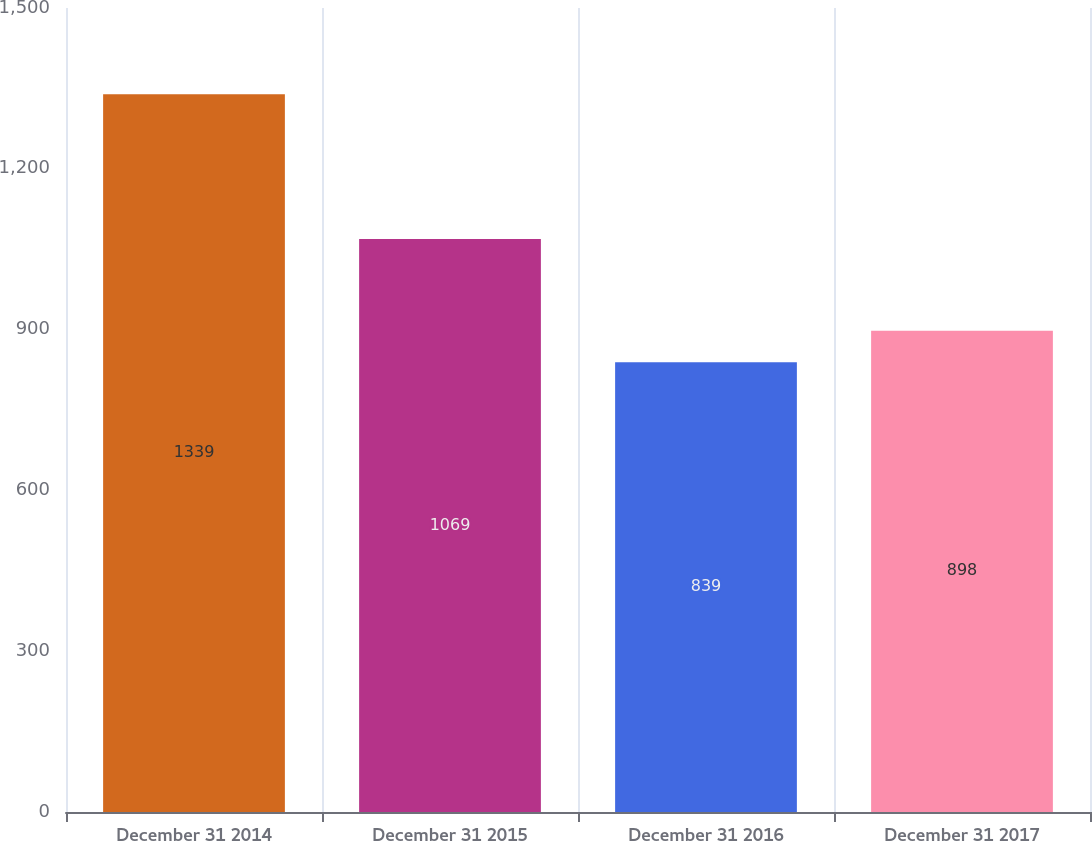Convert chart. <chart><loc_0><loc_0><loc_500><loc_500><bar_chart><fcel>December 31 2014<fcel>December 31 2015<fcel>December 31 2016<fcel>December 31 2017<nl><fcel>1339<fcel>1069<fcel>839<fcel>898<nl></chart> 